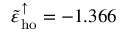<formula> <loc_0><loc_0><loc_500><loc_500>\tilde { \varepsilon } _ { h o } ^ { \uparrow } = - 1 . 3 6 6</formula> 